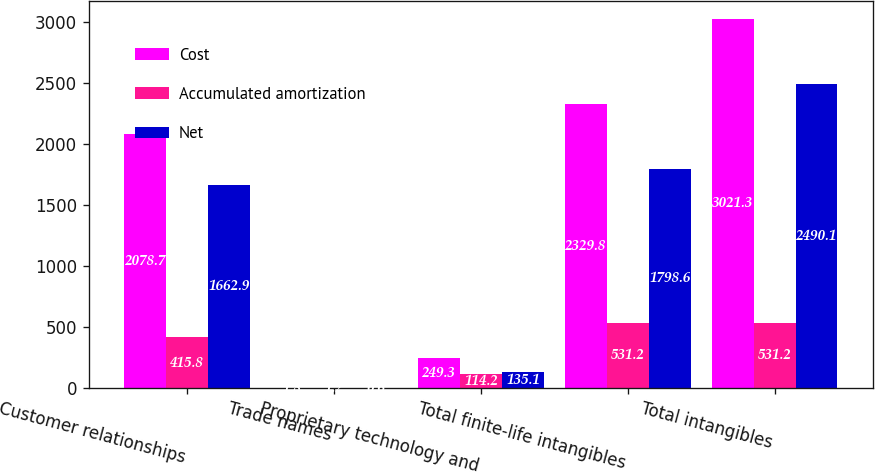<chart> <loc_0><loc_0><loc_500><loc_500><stacked_bar_chart><ecel><fcel>Customer relationships<fcel>Trade names<fcel>Proprietary technology and<fcel>Total finite-life intangibles<fcel>Total intangibles<nl><fcel>Cost<fcel>2078.7<fcel>1.8<fcel>249.3<fcel>2329.8<fcel>3021.3<nl><fcel>Accumulated amortization<fcel>415.8<fcel>1.2<fcel>114.2<fcel>531.2<fcel>531.2<nl><fcel>Net<fcel>1662.9<fcel>0.6<fcel>135.1<fcel>1798.6<fcel>2490.1<nl></chart> 